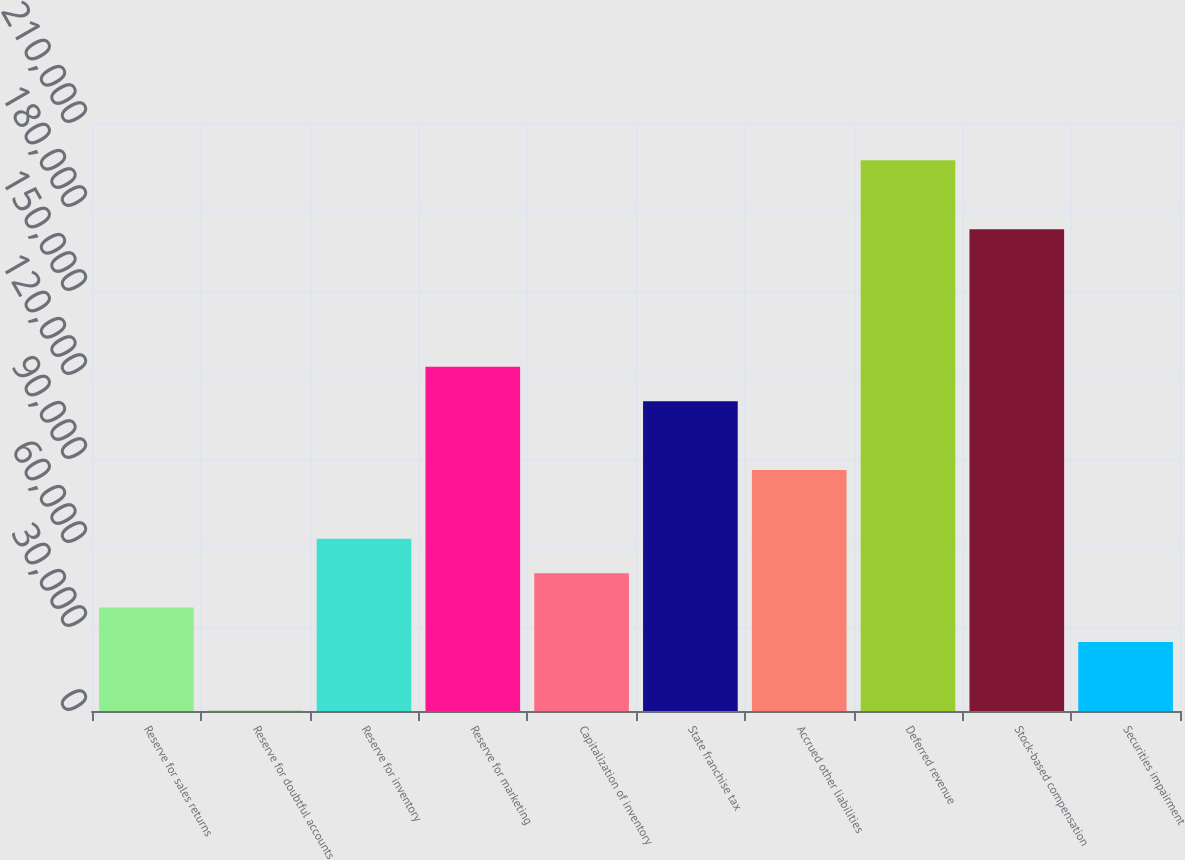Convert chart. <chart><loc_0><loc_0><loc_500><loc_500><bar_chart><fcel>Reserve for sales returns<fcel>Reserve for doubtful accounts<fcel>Reserve for inventory<fcel>Reserve for marketing<fcel>Capitalization of inventory<fcel>State franchise tax<fcel>Accrued other liabilities<fcel>Deferred revenue<fcel>Stock-based compensation<fcel>Securities impairment<nl><fcel>36925.1<fcel>62<fcel>61500.5<fcel>122939<fcel>49212.8<fcel>110651<fcel>86075.9<fcel>196665<fcel>172090<fcel>24637.4<nl></chart> 